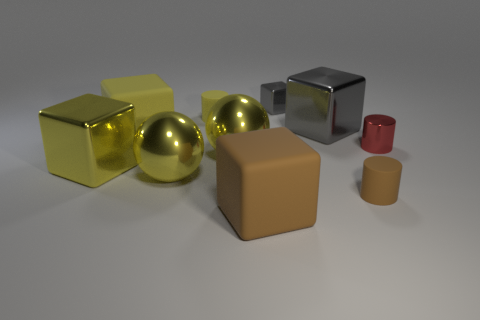Subtract all gray cubes. How many were subtracted if there are1gray cubes left? 1 Subtract all cylinders. How many objects are left? 7 Subtract 1 spheres. How many spheres are left? 1 Subtract all purple cylinders. Subtract all blue spheres. How many cylinders are left? 3 Subtract all gray spheres. How many cyan cubes are left? 0 Subtract all yellow metallic cubes. Subtract all small red shiny things. How many objects are left? 8 Add 1 yellow metal things. How many yellow metal things are left? 4 Add 9 tiny metallic blocks. How many tiny metallic blocks exist? 10 Subtract all gray blocks. How many blocks are left? 3 Subtract all tiny yellow rubber cylinders. How many cylinders are left? 2 